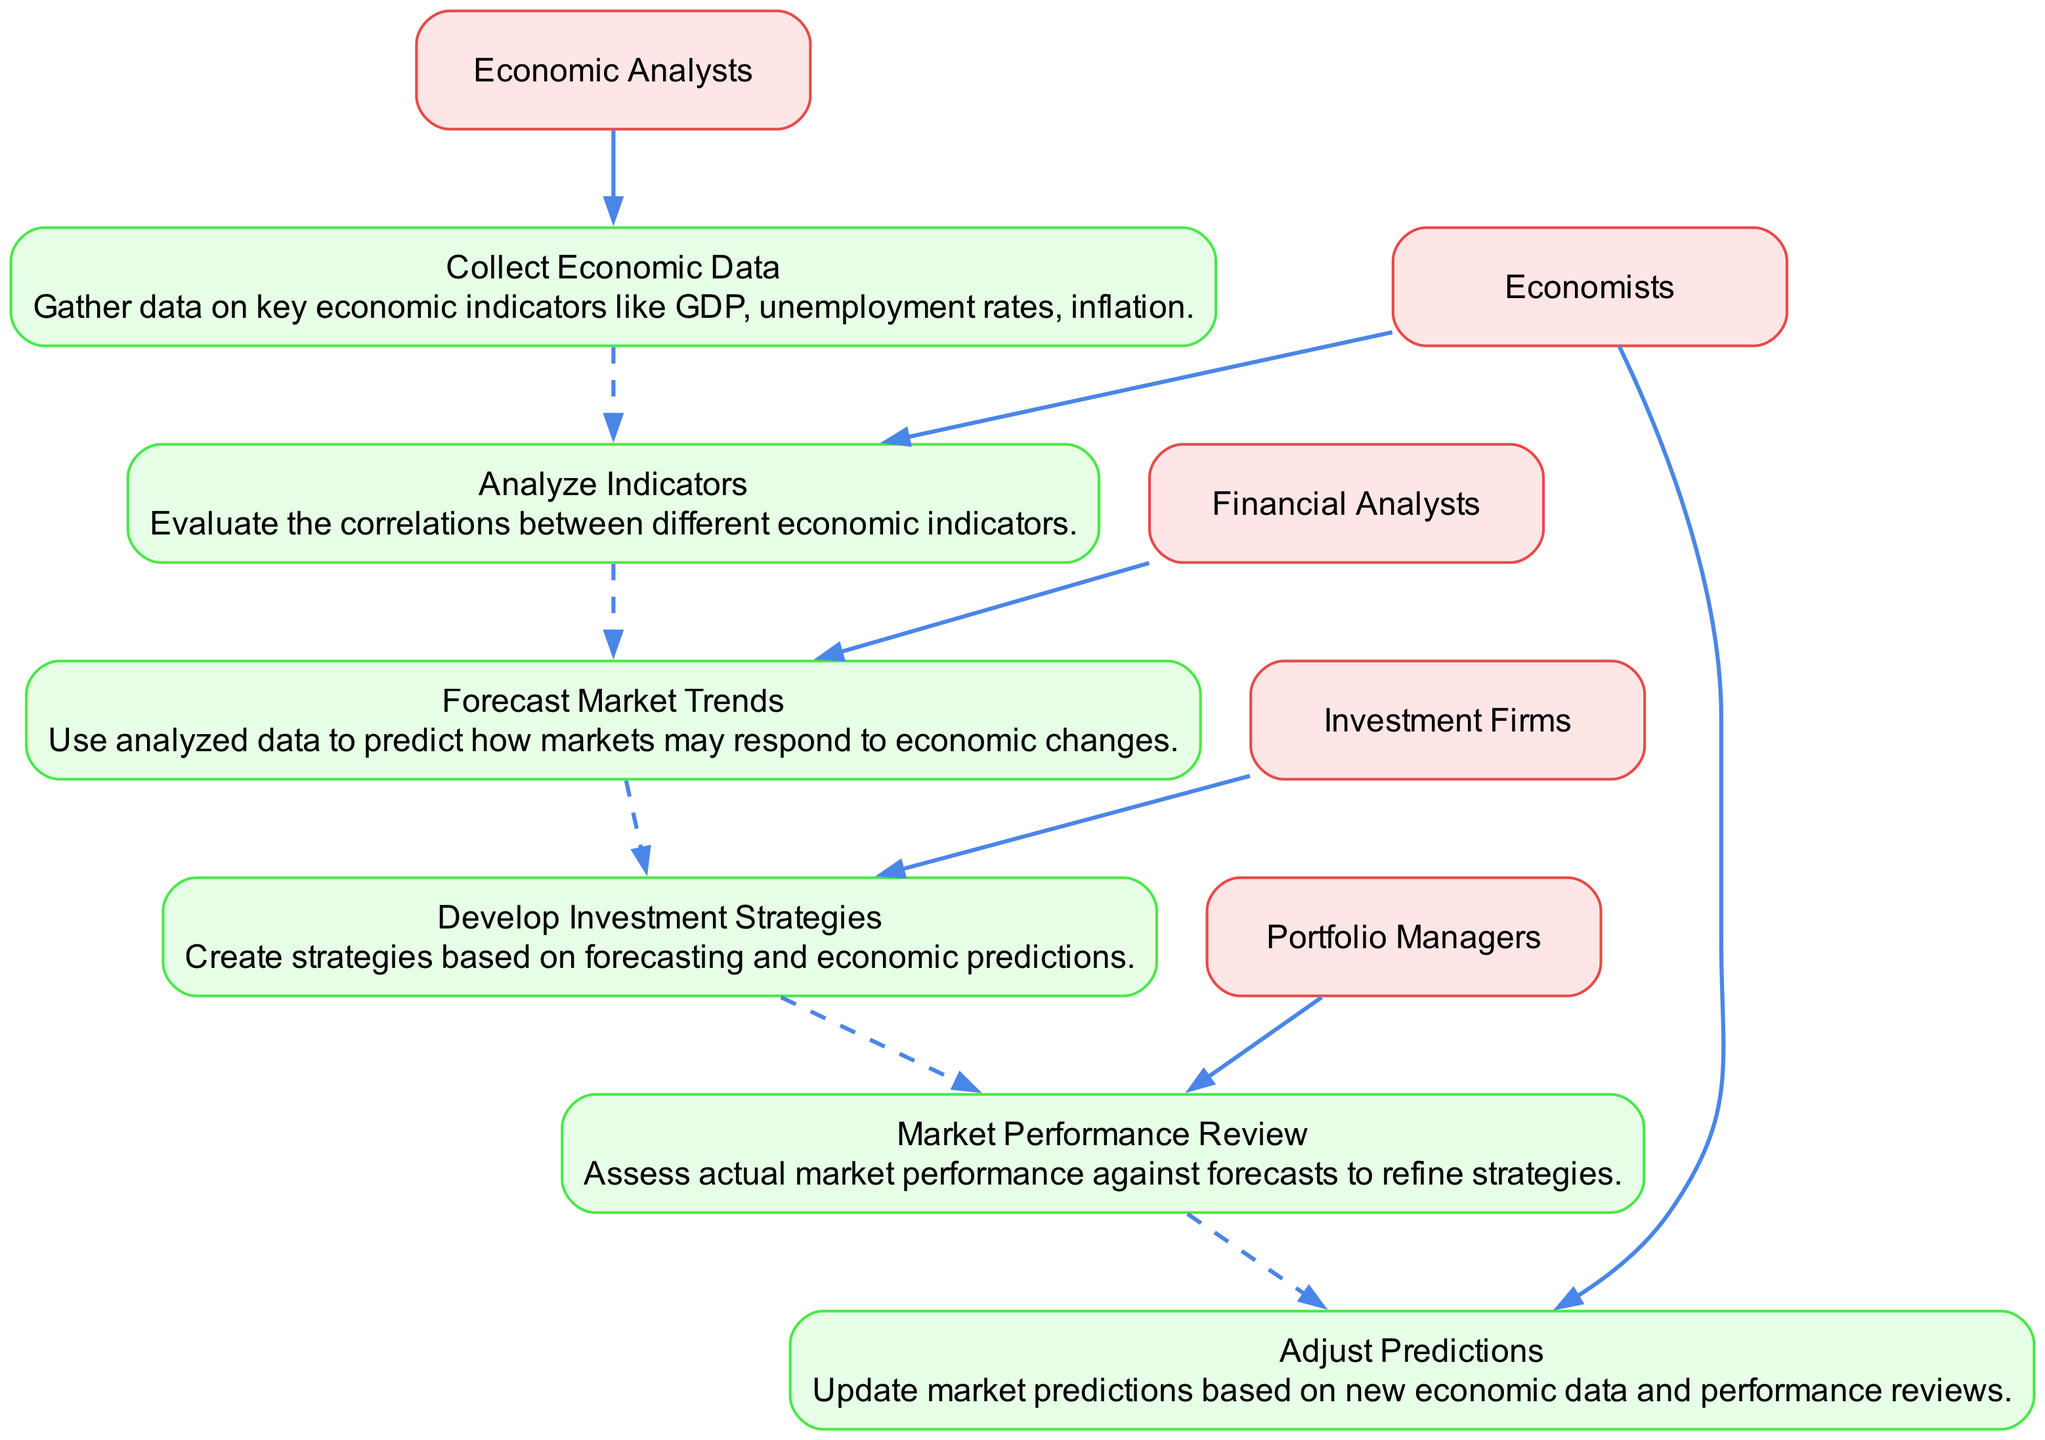What is the first event in the sequence? The first event listed in the diagram is "Collect Economic Data," which indicates the initial step in the financial forecasting process.
Answer: Collect Economic Data Who are the Economic Analysts? Economic Analysts are the individuals responsible for the first event, "Collect Economic Data," showcasing their defined role in the diagram.
Answer: Economic Analysts How many events are shown in the diagram? The diagram features six distinct events, which represent the critical steps in the financial forecasting process.
Answer: Six What is the last event in the sequence? The last event presented is "Adjust Predictions," which suggests the final step following the review of market performance.
Answer: Adjust Predictions Which entities are involved in "Develop Investment Strategies"? The "Develop Investment Strategies" event is linked to the entity "Investment Firms," who create strategies based on previous forecasting events.
Answer: Investment Firms What do Portfolio Managers assess against forecasts? Portfolio Managers conduct a "Market Performance Review," comparing actual market performance to earlier forecasts to make informed adjustments.
Answer: Actual market performance What do Economists do after assessing performance? Economists "Adjust Predictions" based on the latest economic data and performance reviews, reflecting their ongoing role in the forecasting cycle.
Answer: Adjust Predictions Which event is correlated directly with "Analyze Indicators"? The event "Analyze Indicators" is directly followed by "Forecast Market Trends," indicating that trend forecasting relies on the results of indicator analysis.
Answer: Forecast Market Trends What type of diagram is represented? The structure and flow of the events indicate that this is a sequence diagram, specifically detailing the order of events in financial forecasting.
Answer: Sequence diagram 